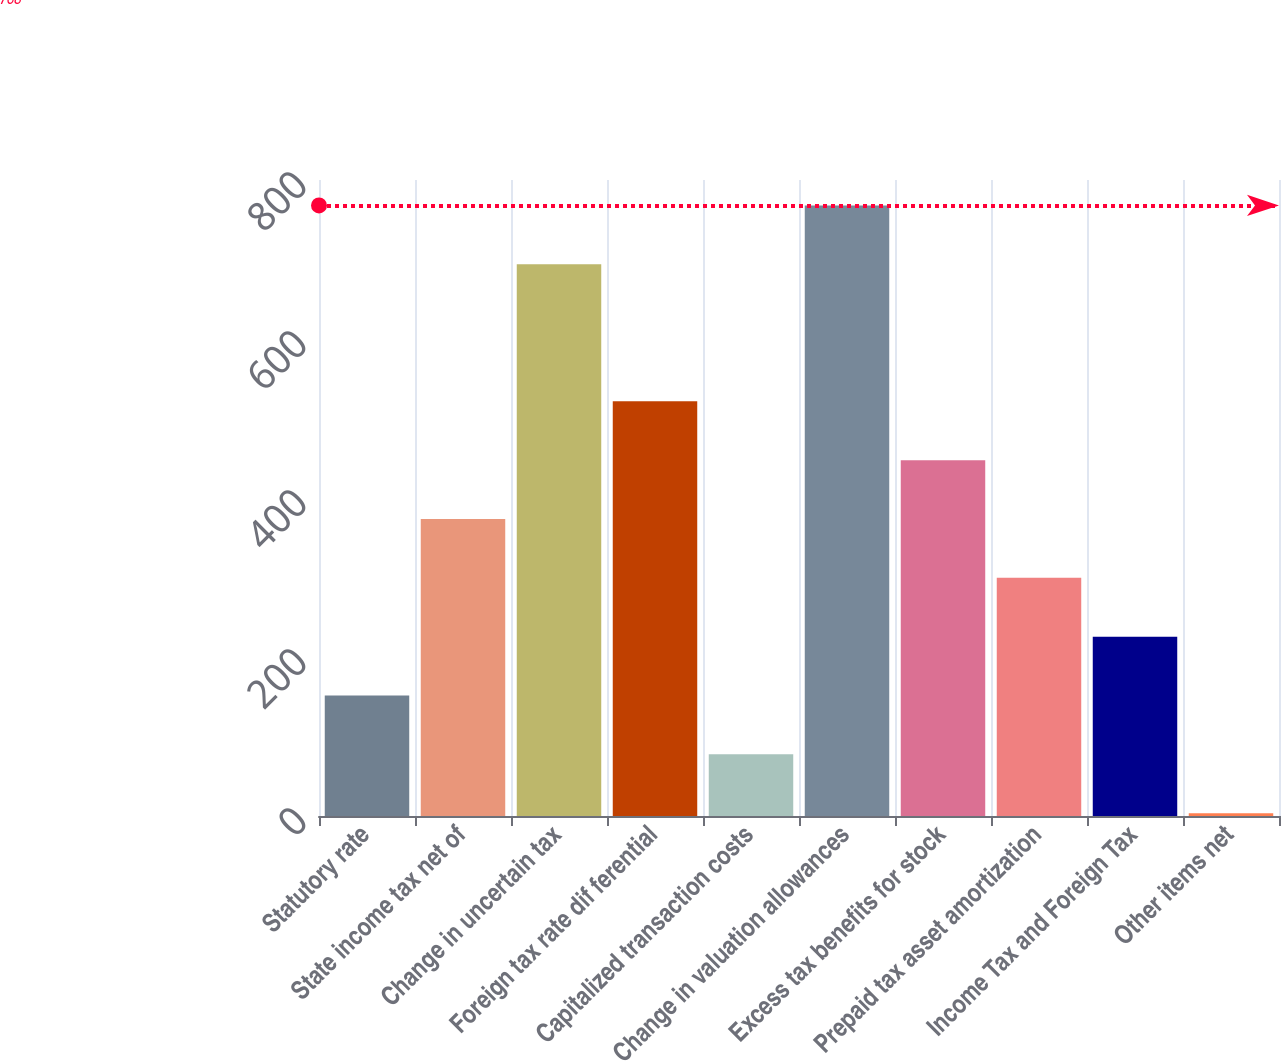<chart> <loc_0><loc_0><loc_500><loc_500><bar_chart><fcel>Statutory rate<fcel>State income tax net of<fcel>Change in uncertain tax<fcel>Foreign tax rate dif ferential<fcel>Capitalized transaction costs<fcel>Change in valuation allowances<fcel>Excess tax benefits for stock<fcel>Prepaid tax asset amortization<fcel>Income Tax and Foreign Tax<fcel>Other items net<nl><fcel>151.6<fcel>373.6<fcel>694<fcel>521.6<fcel>77.6<fcel>768<fcel>447.6<fcel>299.6<fcel>225.6<fcel>3.6<nl></chart> 